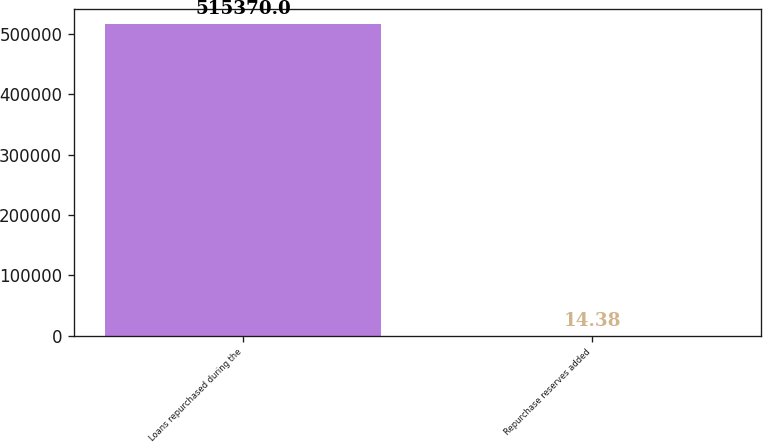Convert chart. <chart><loc_0><loc_0><loc_500><loc_500><bar_chart><fcel>Loans repurchased during the<fcel>Repurchase reserves added<nl><fcel>515370<fcel>14.38<nl></chart> 